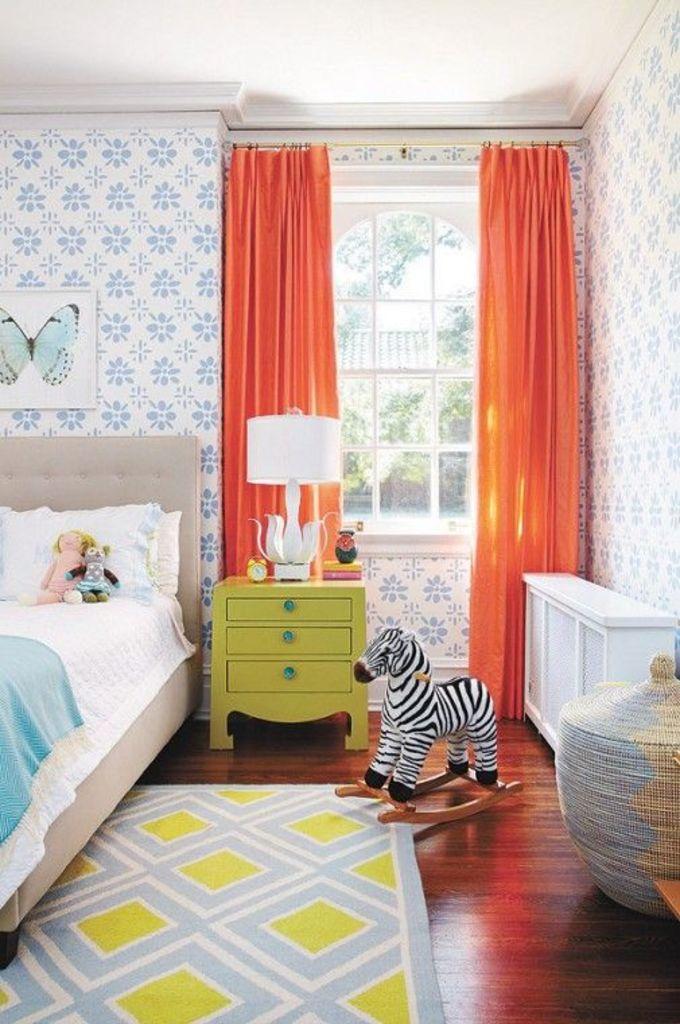How would you summarize this image in a sentence or two? This is a picture of a room. On the right there is a closet. In the center background there is a window, through the window a house and tree is visible. Wall is having floral design. In the center of the image there is zebra toy and a lamp, alarm and a box. On the left there is a bed and two dolls on it. On the top left there is a butterfly frame. 